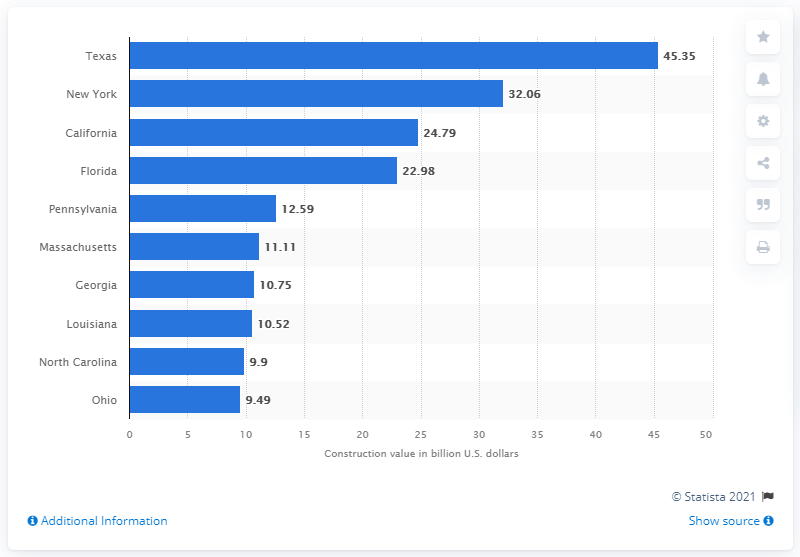List a handful of essential elements in this visual. In 2019, the value of private sector non-residential construction in Texas was $45.35. 